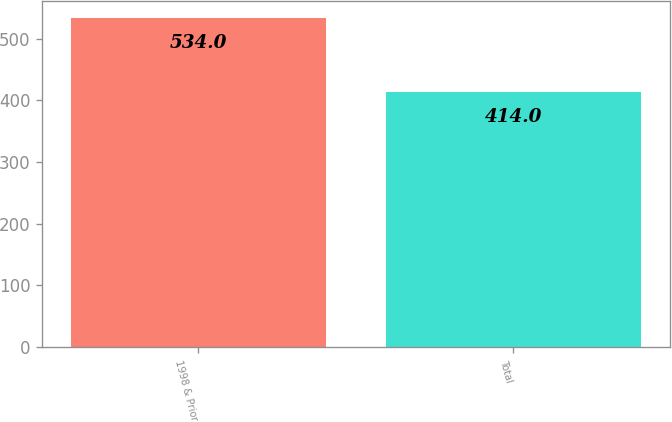<chart> <loc_0><loc_0><loc_500><loc_500><bar_chart><fcel>1998 & Prior<fcel>Total<nl><fcel>534<fcel>414<nl></chart> 